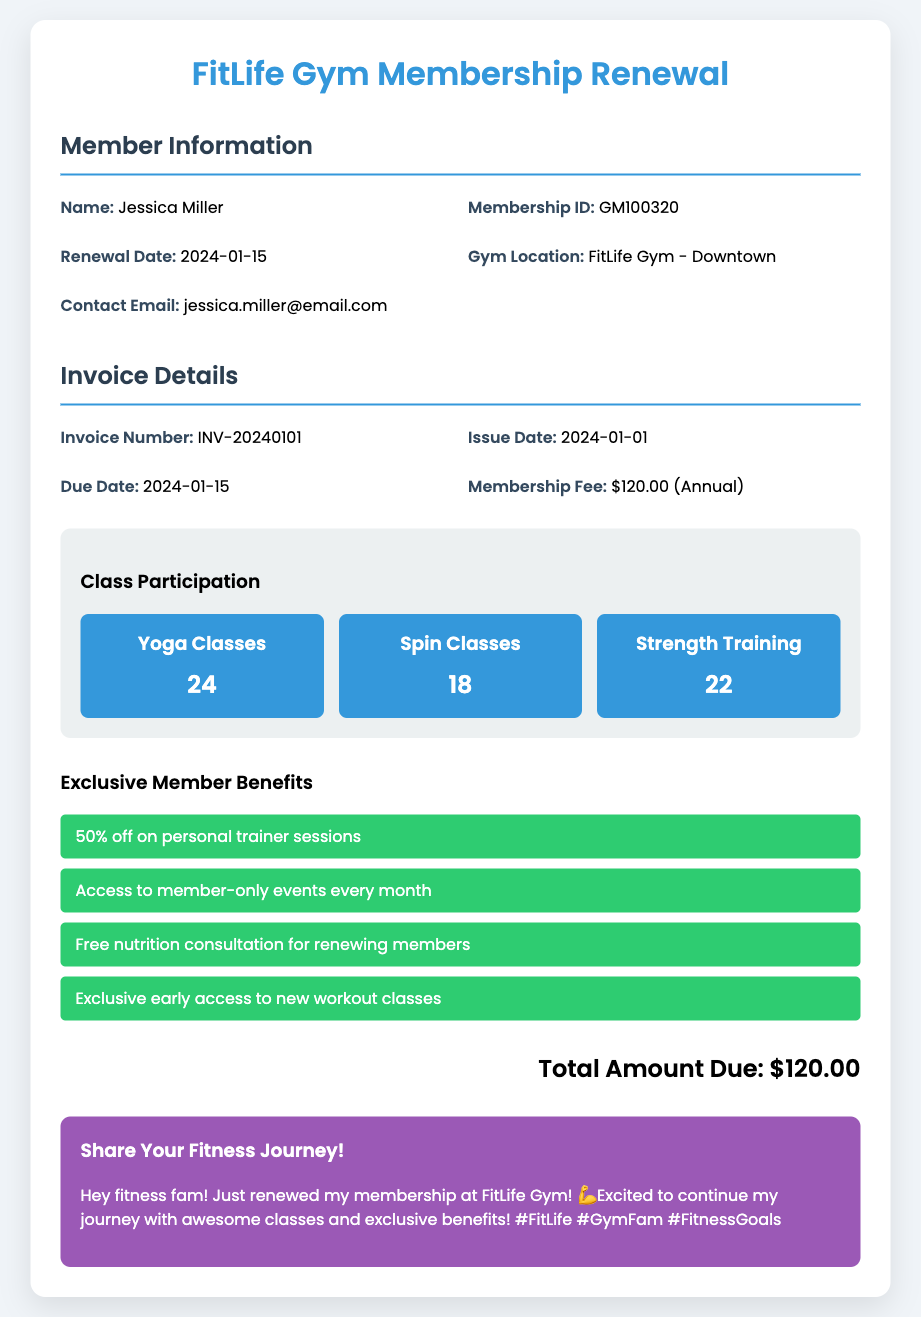What is the member's name? The member's name is displayed clearly in the member information section.
Answer: Jessica Miller What is the membership ID? The membership ID is a unique identifier for the member, found in the member info section.
Answer: GM100320 What is the renewal date? This date indicates when the membership will be renewed, located in the member info.
Answer: 2024-01-15 How many Yoga classes did the member participate in? The number of Yoga classes is listed under class participation.
Answer: 24 What is the membership fee? The membership fee is stated in the invoice details section.
Answer: $120.00 (Annual) What are the member benefits? The exclusive benefits available to the member are displayed in a list format.
Answer: 50% off on personal trainer sessions What is the total amount due? This is the final charge that the member has to pay as shown in the invoice details.
Answer: $120.00 What gym location is listed? This specifies where the member's fitness activities take place, found in the member info.
Answer: FitLife Gym - Downtown How many Spin classes did the member participate in? This is another participation metric that shows engagement in the workout classes.
Answer: 18 